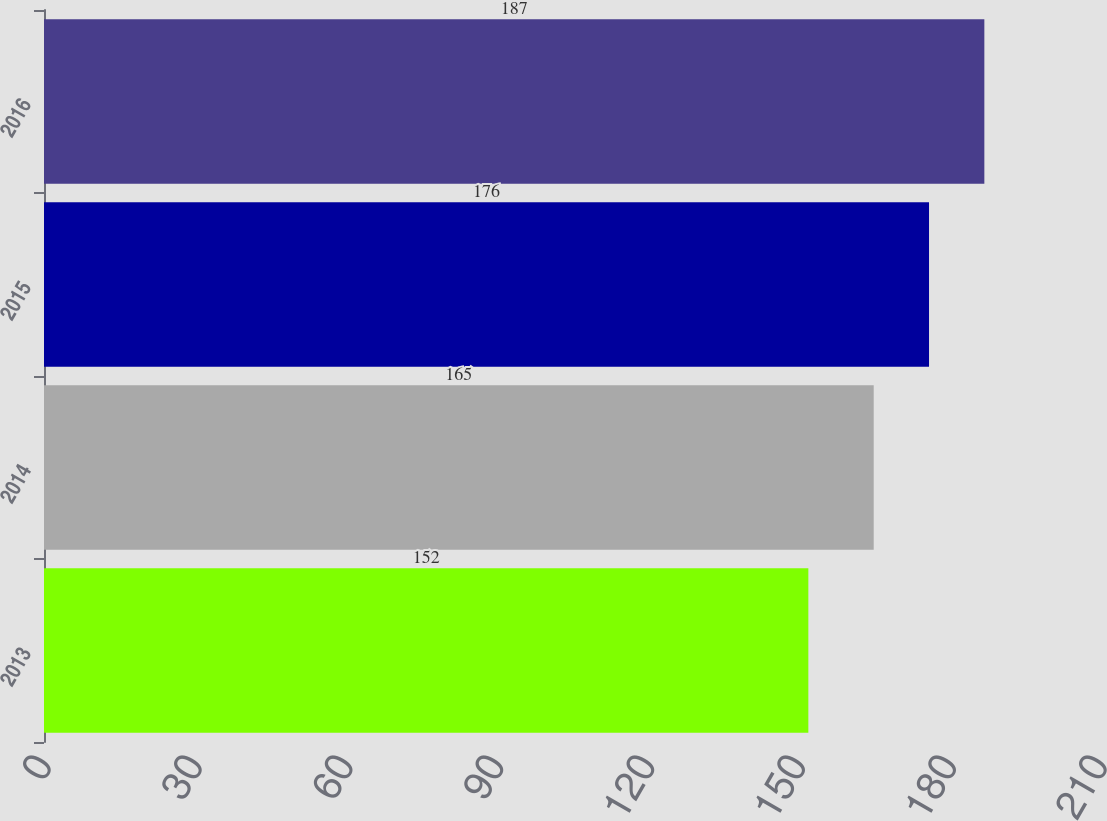<chart> <loc_0><loc_0><loc_500><loc_500><bar_chart><fcel>2013<fcel>2014<fcel>2015<fcel>2016<nl><fcel>152<fcel>165<fcel>176<fcel>187<nl></chart> 